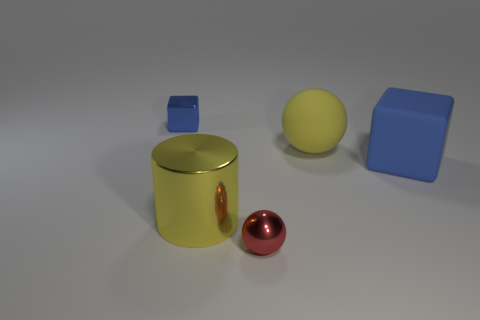What shape is the object that is the same color as the tiny metallic block?
Your response must be concise. Cube. Do the tiny shiny block and the rubber block have the same color?
Offer a terse response. Yes. Is the shape of the red thing the same as the blue object right of the metallic cylinder?
Your answer should be compact. No. What number of cubes are small blue objects or small objects?
Your answer should be very brief. 1. The tiny metallic thing that is behind the large shiny cylinder has what shape?
Ensure brevity in your answer.  Cube. What number of big objects have the same material as the large block?
Offer a very short reply. 1. Is the number of large blue cubes left of the yellow ball less than the number of tiny red metallic spheres?
Keep it short and to the point. Yes. There is a blue block that is on the right side of the sphere in front of the rubber cube; what size is it?
Ensure brevity in your answer.  Large. There is a small block; is it the same color as the block that is on the right side of the yellow metal cylinder?
Offer a terse response. Yes. What is the material of the red sphere that is the same size as the metallic cube?
Give a very brief answer. Metal. 